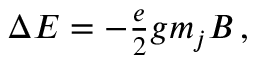Convert formula to latex. <formula><loc_0><loc_0><loc_500><loc_500>\begin{array} { r } { \Delta E = - \frac { e } { 2 } g m _ { j } B \, , } \end{array}</formula> 